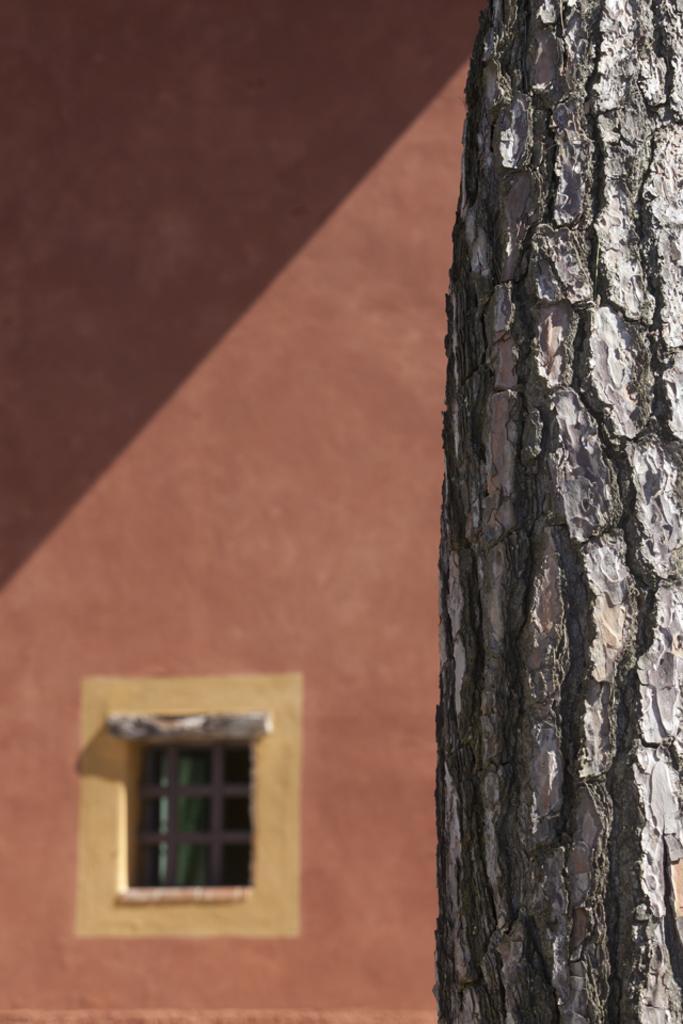Please provide a concise description of this image. In this picture we can see a tree trunk and in the background we can see a window, wall. 